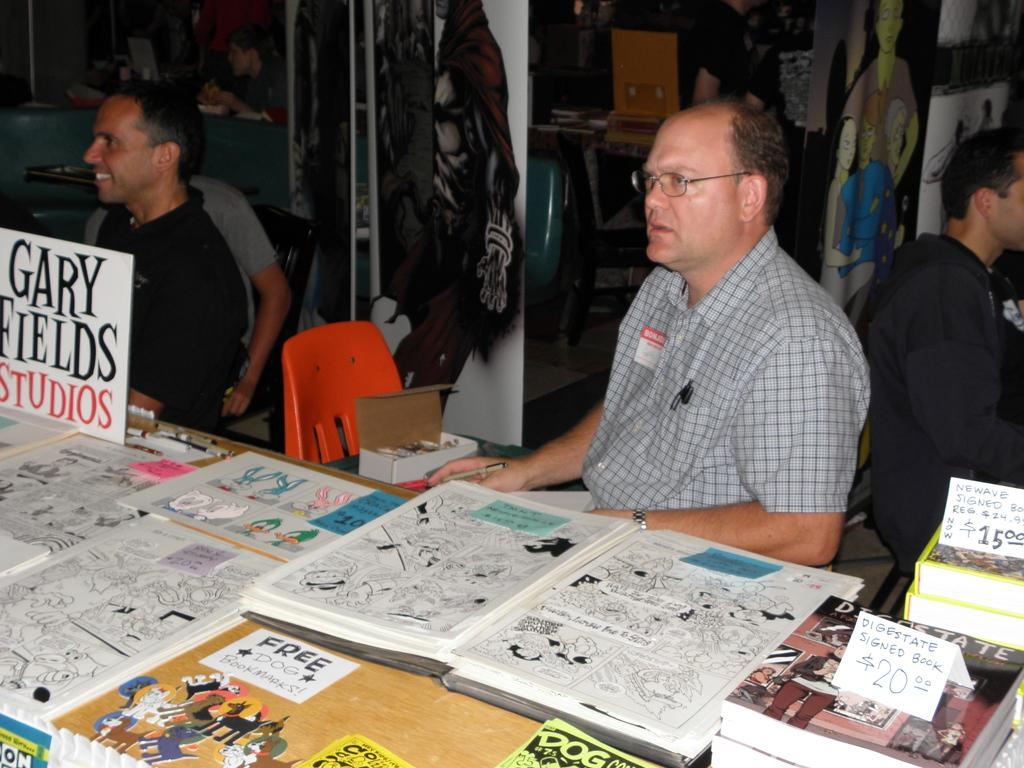<image>
Share a concise interpretation of the image provided. Two men sit at a table and one has a sign with Gary Field Studios in front of him. 